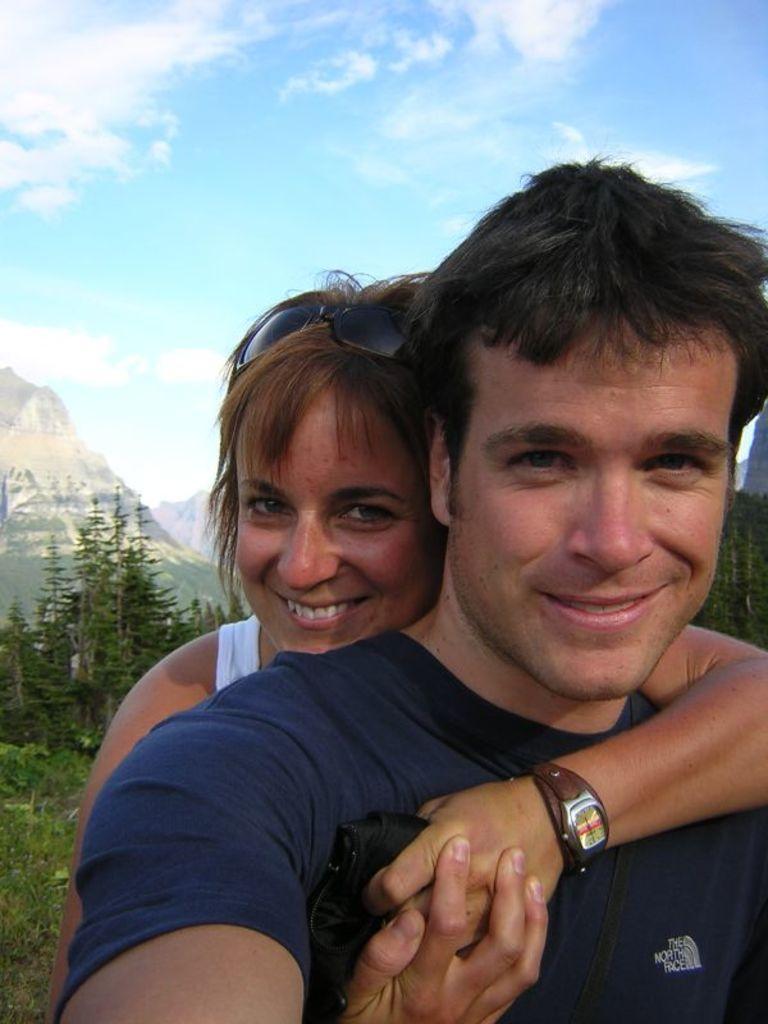Could you give a brief overview of what you see in this image? In this picture there is a boy and a girl in the center of the image and there is greenery in the background area of the image. 